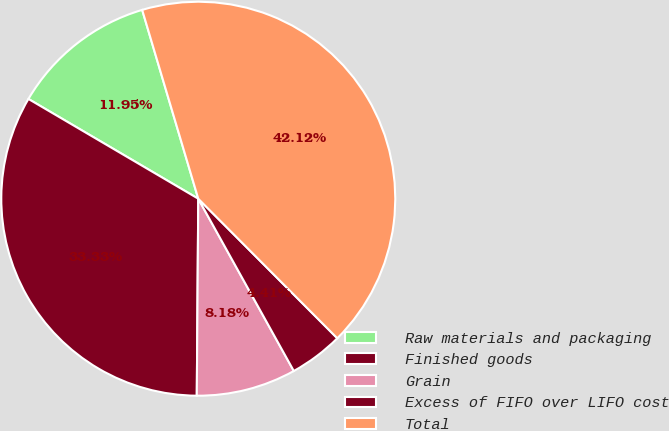Convert chart to OTSL. <chart><loc_0><loc_0><loc_500><loc_500><pie_chart><fcel>Raw materials and packaging<fcel>Finished goods<fcel>Grain<fcel>Excess of FIFO over LIFO cost<fcel>Total<nl><fcel>11.95%<fcel>33.33%<fcel>8.18%<fcel>4.41%<fcel>42.12%<nl></chart> 